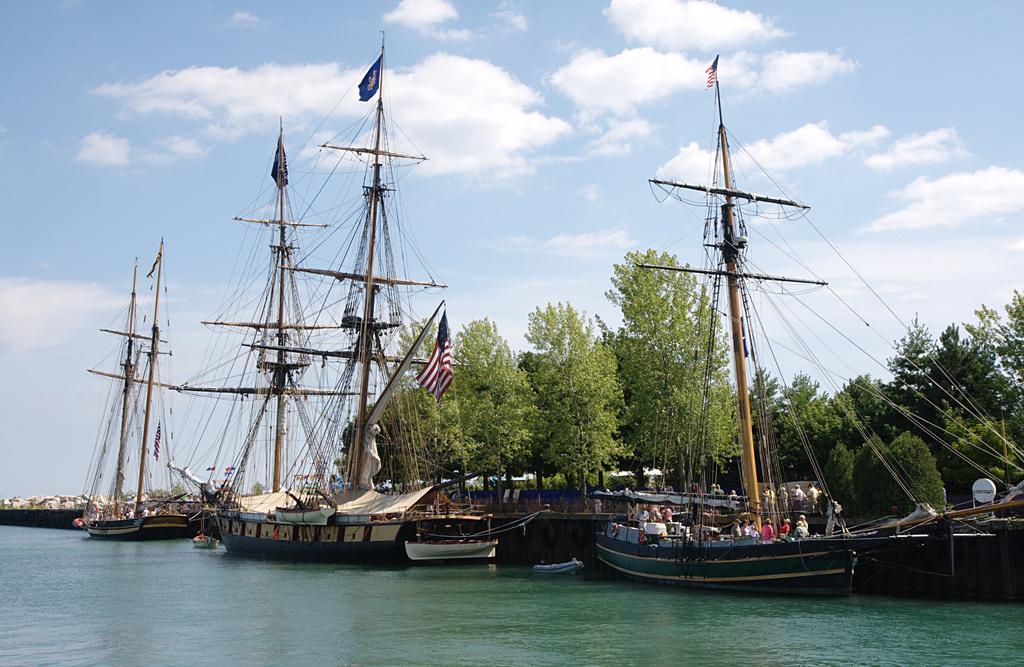Please provide a concise description of this image. In this image at the bottom, there is water. In the middle there are boats, flags, cables, some people, trees, sky and clouds. 